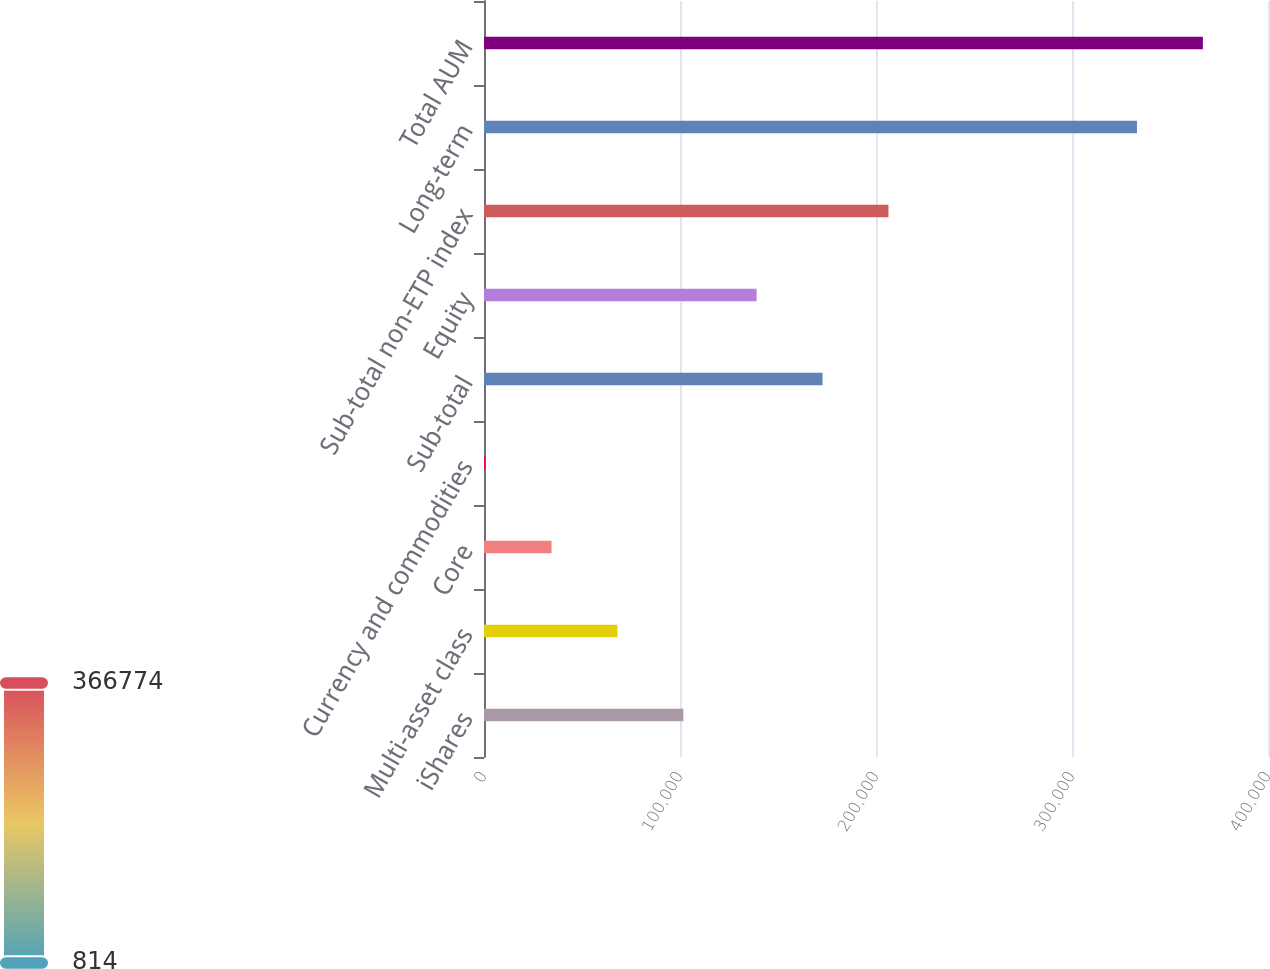Convert chart to OTSL. <chart><loc_0><loc_0><loc_500><loc_500><bar_chart><fcel>iShares<fcel>Multi-asset class<fcel>Core<fcel>Currency and commodities<fcel>Sub-total<fcel>Equity<fcel>Sub-total non-ETP index<fcel>Long-term<fcel>Total AUM<nl><fcel>101706<fcel>68075.6<fcel>34444.8<fcel>814<fcel>172721<fcel>139090<fcel>206352<fcel>333143<fcel>366774<nl></chart> 